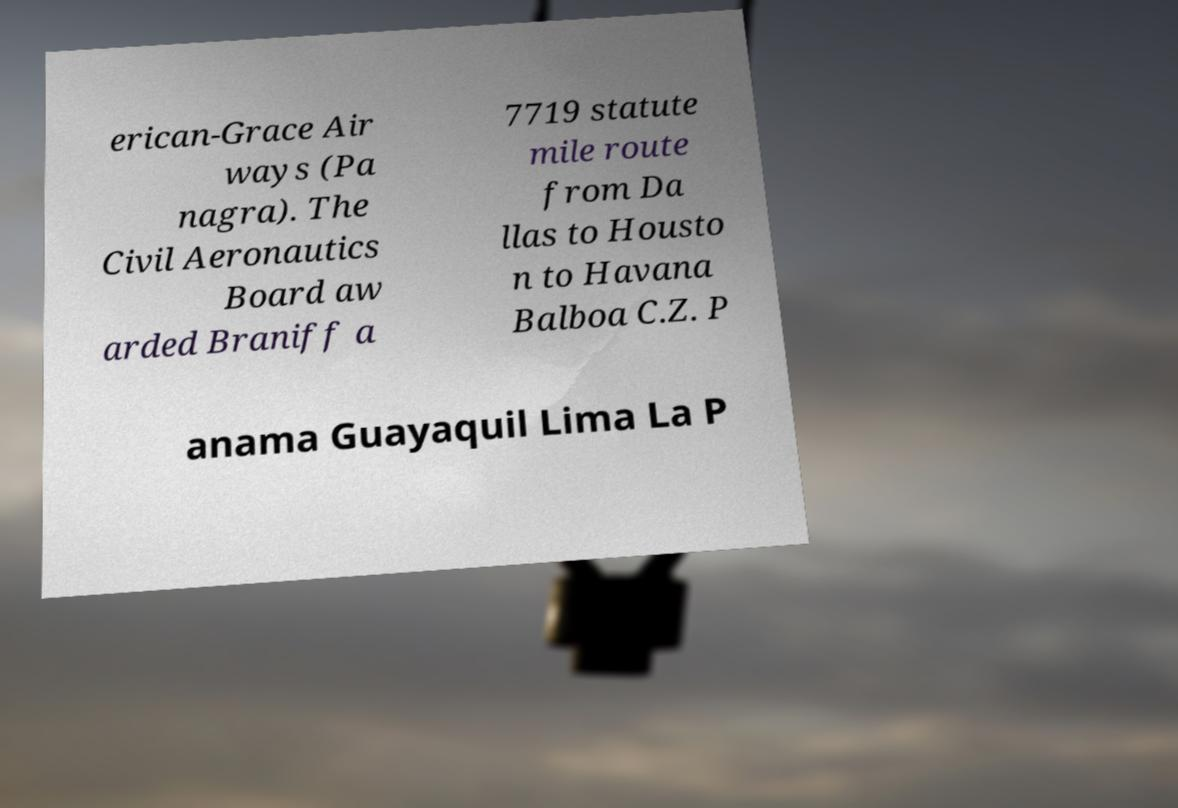There's text embedded in this image that I need extracted. Can you transcribe it verbatim? erican-Grace Air ways (Pa nagra). The Civil Aeronautics Board aw arded Braniff a 7719 statute mile route from Da llas to Housto n to Havana Balboa C.Z. P anama Guayaquil Lima La P 